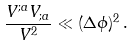Convert formula to latex. <formula><loc_0><loc_0><loc_500><loc_500>\frac { V ^ { ; a } V _ { ; a } } { V ^ { 2 } } \ll ( \Delta \phi ) ^ { 2 } \, .</formula> 